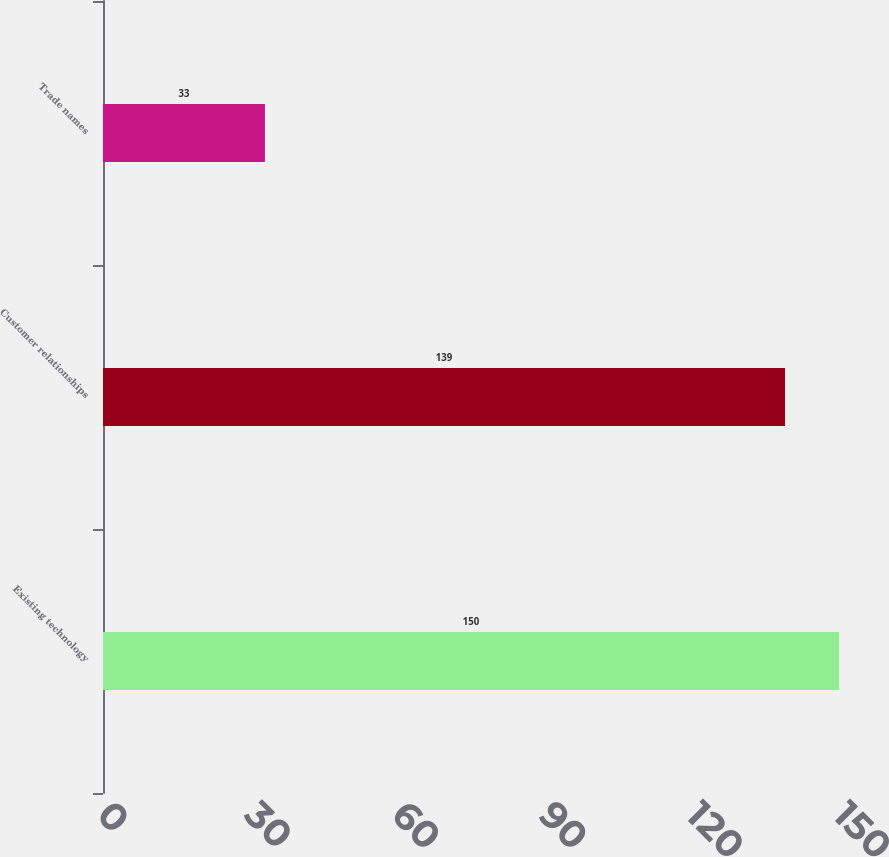Convert chart to OTSL. <chart><loc_0><loc_0><loc_500><loc_500><bar_chart><fcel>Existing technology<fcel>Customer relationships<fcel>Trade names<nl><fcel>150<fcel>139<fcel>33<nl></chart> 